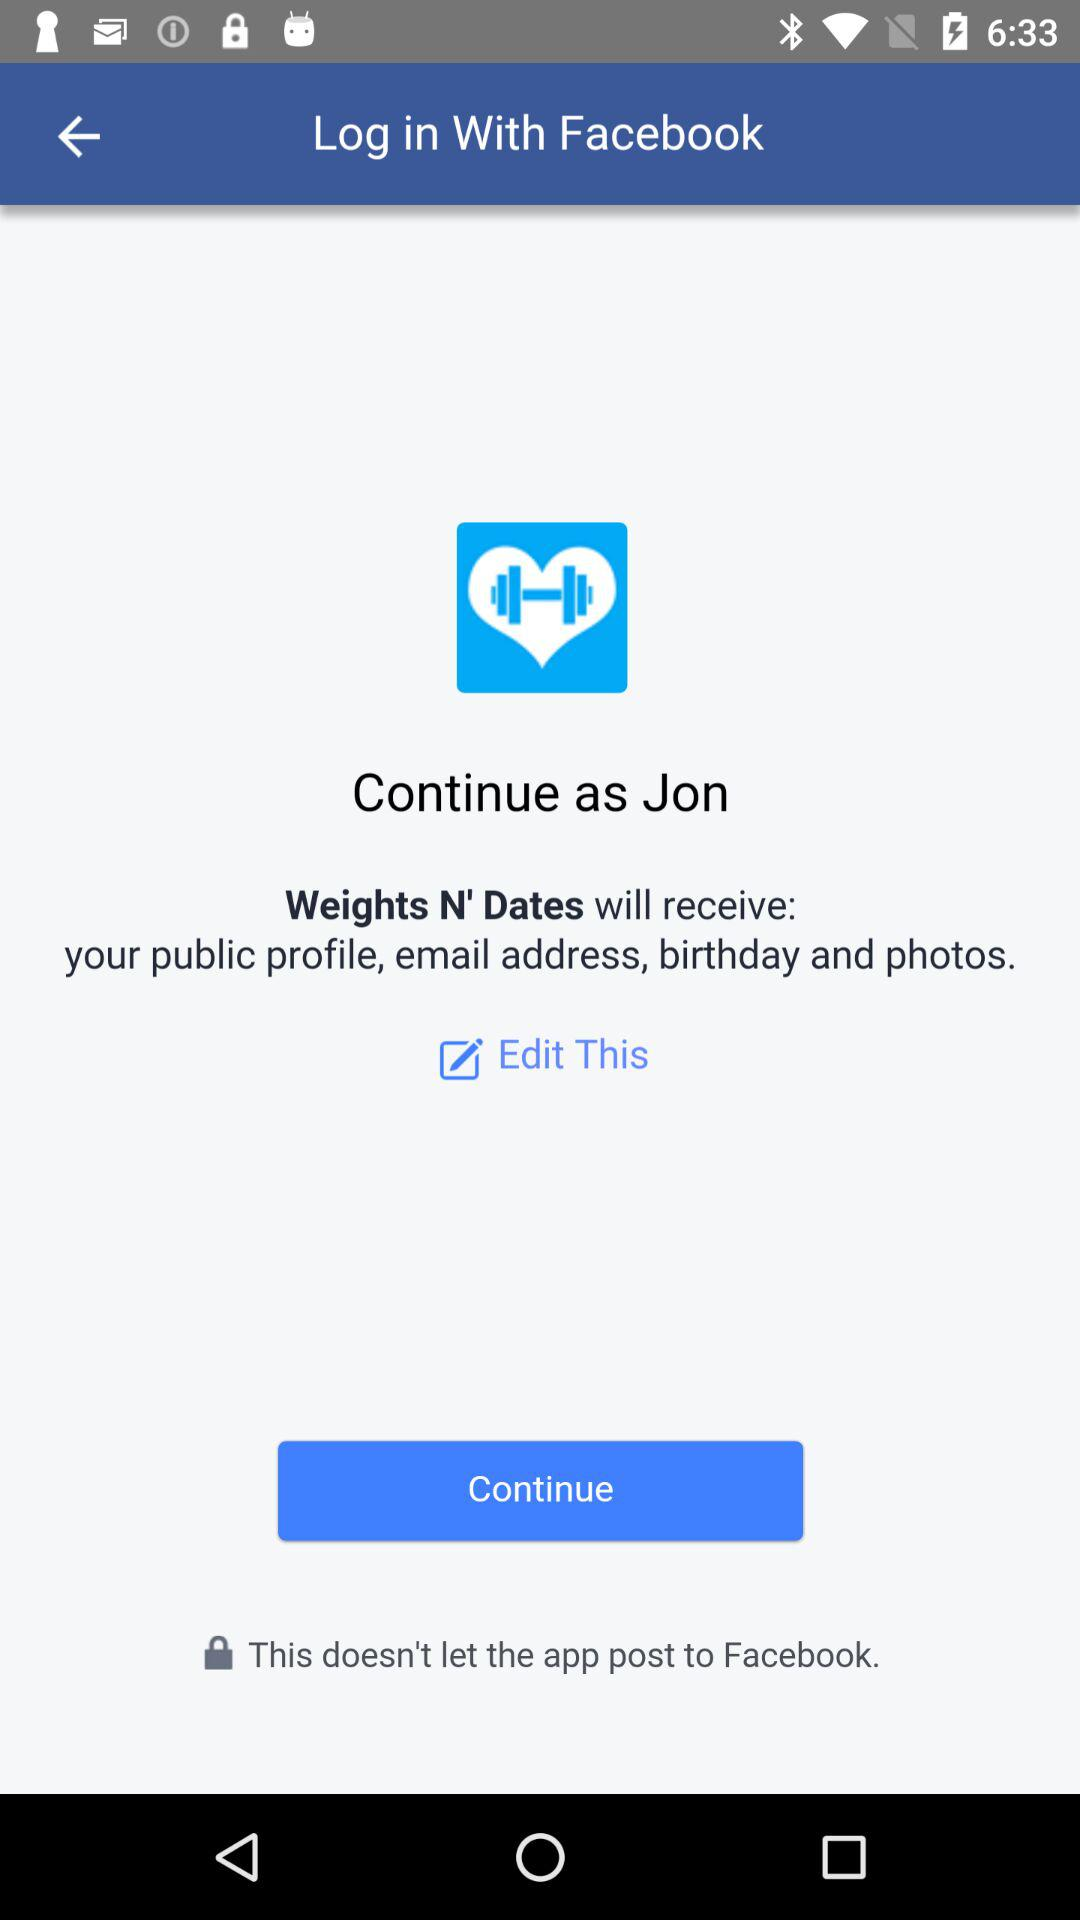What application is asking for permission? The application asking for permission is "Weights N' Dates". 